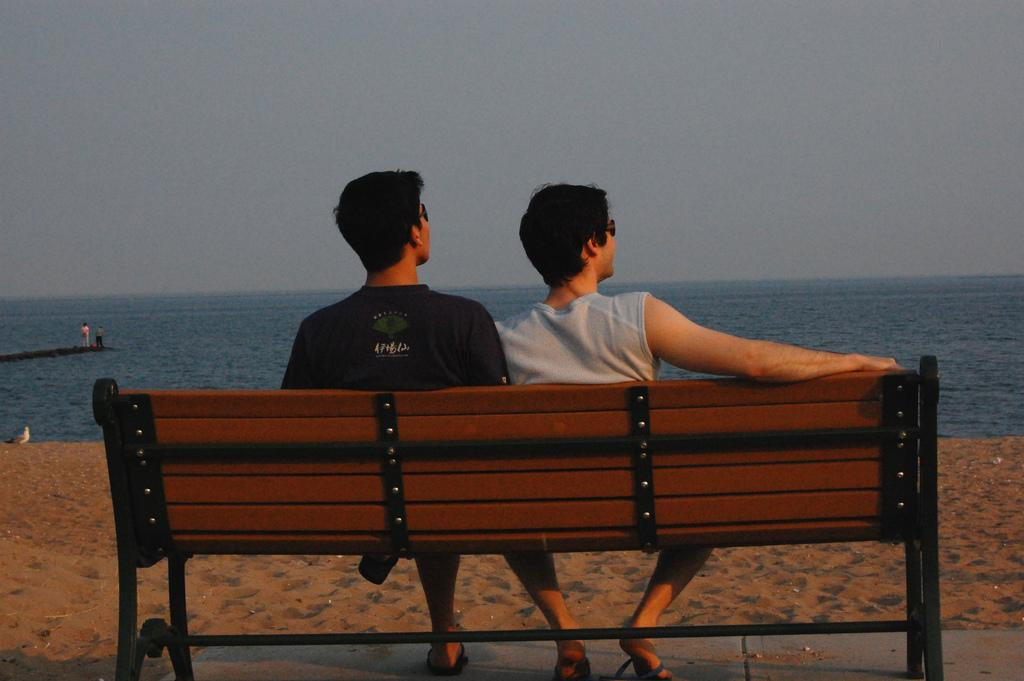What are the two men in the image doing? The two men are sitting on a bench in the image. Can you describe any other people visible in the image? Yes, there are other people visible in the image. What is the presence of water in the image indicative of? The presence of water in the image suggests that the location might be near a body of water or in a wet environment. What type of dress is the horse wearing in the image? There is no horse present in the image, so it is not possible to answer that question. 